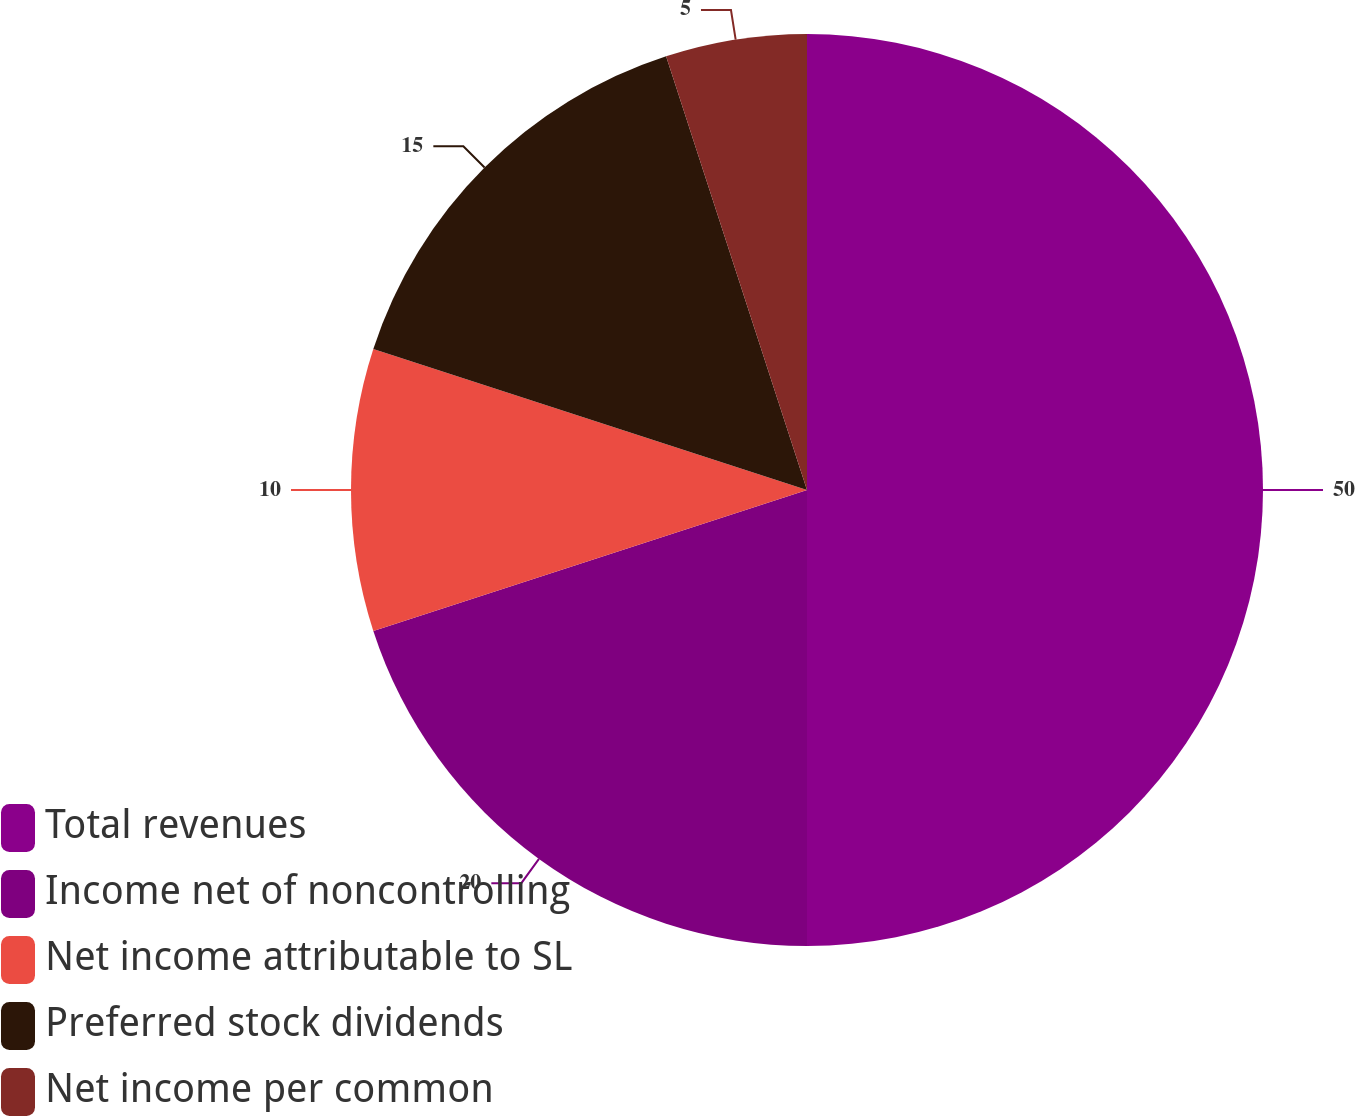Convert chart. <chart><loc_0><loc_0><loc_500><loc_500><pie_chart><fcel>Total revenues<fcel>Income net of noncontrolling<fcel>Net income attributable to SL<fcel>Preferred stock dividends<fcel>Net income per common<nl><fcel>50.0%<fcel>20.0%<fcel>10.0%<fcel>15.0%<fcel>5.0%<nl></chart> 